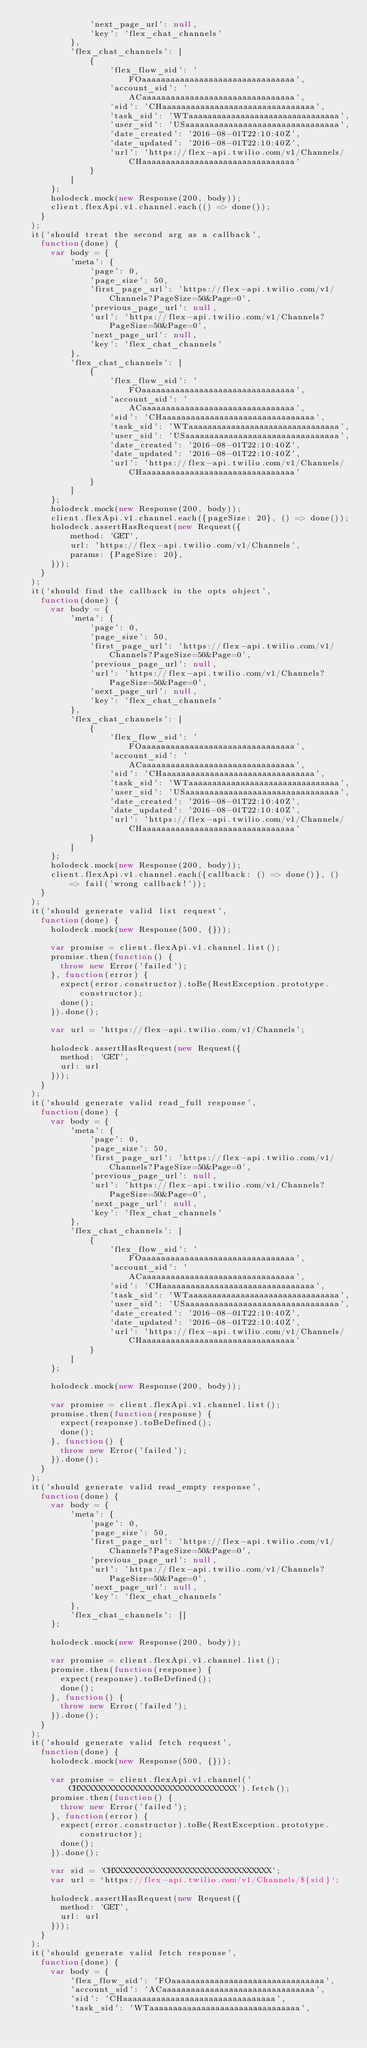Convert code to text. <code><loc_0><loc_0><loc_500><loc_500><_JavaScript_>              'next_page_url': null,
              'key': 'flex_chat_channels'
          },
          'flex_chat_channels': [
              {
                  'flex_flow_sid': 'FOaaaaaaaaaaaaaaaaaaaaaaaaaaaaaaaa',
                  'account_sid': 'ACaaaaaaaaaaaaaaaaaaaaaaaaaaaaaaaa',
                  'sid': 'CHaaaaaaaaaaaaaaaaaaaaaaaaaaaaaaaa',
                  'task_sid': 'WTaaaaaaaaaaaaaaaaaaaaaaaaaaaaaaaa',
                  'user_sid': 'USaaaaaaaaaaaaaaaaaaaaaaaaaaaaaaaa',
                  'date_created': '2016-08-01T22:10:40Z',
                  'date_updated': '2016-08-01T22:10:40Z',
                  'url': 'https://flex-api.twilio.com/v1/Channels/CHaaaaaaaaaaaaaaaaaaaaaaaaaaaaaaaa'
              }
          ]
      };
      holodeck.mock(new Response(200, body));
      client.flexApi.v1.channel.each(() => done());
    }
  );
  it('should treat the second arg as a callback',
    function(done) {
      var body = {
          'meta': {
              'page': 0,
              'page_size': 50,
              'first_page_url': 'https://flex-api.twilio.com/v1/Channels?PageSize=50&Page=0',
              'previous_page_url': null,
              'url': 'https://flex-api.twilio.com/v1/Channels?PageSize=50&Page=0',
              'next_page_url': null,
              'key': 'flex_chat_channels'
          },
          'flex_chat_channels': [
              {
                  'flex_flow_sid': 'FOaaaaaaaaaaaaaaaaaaaaaaaaaaaaaaaa',
                  'account_sid': 'ACaaaaaaaaaaaaaaaaaaaaaaaaaaaaaaaa',
                  'sid': 'CHaaaaaaaaaaaaaaaaaaaaaaaaaaaaaaaa',
                  'task_sid': 'WTaaaaaaaaaaaaaaaaaaaaaaaaaaaaaaaa',
                  'user_sid': 'USaaaaaaaaaaaaaaaaaaaaaaaaaaaaaaaa',
                  'date_created': '2016-08-01T22:10:40Z',
                  'date_updated': '2016-08-01T22:10:40Z',
                  'url': 'https://flex-api.twilio.com/v1/Channels/CHaaaaaaaaaaaaaaaaaaaaaaaaaaaaaaaa'
              }
          ]
      };
      holodeck.mock(new Response(200, body));
      client.flexApi.v1.channel.each({pageSize: 20}, () => done());
      holodeck.assertHasRequest(new Request({
          method: 'GET',
          url: 'https://flex-api.twilio.com/v1/Channels',
          params: {PageSize: 20},
      }));
    }
  );
  it('should find the callback in the opts object',
    function(done) {
      var body = {
          'meta': {
              'page': 0,
              'page_size': 50,
              'first_page_url': 'https://flex-api.twilio.com/v1/Channels?PageSize=50&Page=0',
              'previous_page_url': null,
              'url': 'https://flex-api.twilio.com/v1/Channels?PageSize=50&Page=0',
              'next_page_url': null,
              'key': 'flex_chat_channels'
          },
          'flex_chat_channels': [
              {
                  'flex_flow_sid': 'FOaaaaaaaaaaaaaaaaaaaaaaaaaaaaaaaa',
                  'account_sid': 'ACaaaaaaaaaaaaaaaaaaaaaaaaaaaaaaaa',
                  'sid': 'CHaaaaaaaaaaaaaaaaaaaaaaaaaaaaaaaa',
                  'task_sid': 'WTaaaaaaaaaaaaaaaaaaaaaaaaaaaaaaaa',
                  'user_sid': 'USaaaaaaaaaaaaaaaaaaaaaaaaaaaaaaaa',
                  'date_created': '2016-08-01T22:10:40Z',
                  'date_updated': '2016-08-01T22:10:40Z',
                  'url': 'https://flex-api.twilio.com/v1/Channels/CHaaaaaaaaaaaaaaaaaaaaaaaaaaaaaaaa'
              }
          ]
      };
      holodeck.mock(new Response(200, body));
      client.flexApi.v1.channel.each({callback: () => done()}, () => fail('wrong callback!'));
    }
  );
  it('should generate valid list request',
    function(done) {
      holodeck.mock(new Response(500, {}));

      var promise = client.flexApi.v1.channel.list();
      promise.then(function() {
        throw new Error('failed');
      }, function(error) {
        expect(error.constructor).toBe(RestException.prototype.constructor);
        done();
      }).done();

      var url = 'https://flex-api.twilio.com/v1/Channels';

      holodeck.assertHasRequest(new Request({
        method: 'GET',
        url: url
      }));
    }
  );
  it('should generate valid read_full response',
    function(done) {
      var body = {
          'meta': {
              'page': 0,
              'page_size': 50,
              'first_page_url': 'https://flex-api.twilio.com/v1/Channels?PageSize=50&Page=0',
              'previous_page_url': null,
              'url': 'https://flex-api.twilio.com/v1/Channels?PageSize=50&Page=0',
              'next_page_url': null,
              'key': 'flex_chat_channels'
          },
          'flex_chat_channels': [
              {
                  'flex_flow_sid': 'FOaaaaaaaaaaaaaaaaaaaaaaaaaaaaaaaa',
                  'account_sid': 'ACaaaaaaaaaaaaaaaaaaaaaaaaaaaaaaaa',
                  'sid': 'CHaaaaaaaaaaaaaaaaaaaaaaaaaaaaaaaa',
                  'task_sid': 'WTaaaaaaaaaaaaaaaaaaaaaaaaaaaaaaaa',
                  'user_sid': 'USaaaaaaaaaaaaaaaaaaaaaaaaaaaaaaaa',
                  'date_created': '2016-08-01T22:10:40Z',
                  'date_updated': '2016-08-01T22:10:40Z',
                  'url': 'https://flex-api.twilio.com/v1/Channels/CHaaaaaaaaaaaaaaaaaaaaaaaaaaaaaaaa'
              }
          ]
      };

      holodeck.mock(new Response(200, body));

      var promise = client.flexApi.v1.channel.list();
      promise.then(function(response) {
        expect(response).toBeDefined();
        done();
      }, function() {
        throw new Error('failed');
      }).done();
    }
  );
  it('should generate valid read_empty response',
    function(done) {
      var body = {
          'meta': {
              'page': 0,
              'page_size': 50,
              'first_page_url': 'https://flex-api.twilio.com/v1/Channels?PageSize=50&Page=0',
              'previous_page_url': null,
              'url': 'https://flex-api.twilio.com/v1/Channels?PageSize=50&Page=0',
              'next_page_url': null,
              'key': 'flex_chat_channels'
          },
          'flex_chat_channels': []
      };

      holodeck.mock(new Response(200, body));

      var promise = client.flexApi.v1.channel.list();
      promise.then(function(response) {
        expect(response).toBeDefined();
        done();
      }, function() {
        throw new Error('failed');
      }).done();
    }
  );
  it('should generate valid fetch request',
    function(done) {
      holodeck.mock(new Response(500, {}));

      var promise = client.flexApi.v1.channel('CHXXXXXXXXXXXXXXXXXXXXXXXXXXXXXXXX').fetch();
      promise.then(function() {
        throw new Error('failed');
      }, function(error) {
        expect(error.constructor).toBe(RestException.prototype.constructor);
        done();
      }).done();

      var sid = 'CHXXXXXXXXXXXXXXXXXXXXXXXXXXXXXXXX';
      var url = `https://flex-api.twilio.com/v1/Channels/${sid}`;

      holodeck.assertHasRequest(new Request({
        method: 'GET',
        url: url
      }));
    }
  );
  it('should generate valid fetch response',
    function(done) {
      var body = {
          'flex_flow_sid': 'FOaaaaaaaaaaaaaaaaaaaaaaaaaaaaaaaa',
          'account_sid': 'ACaaaaaaaaaaaaaaaaaaaaaaaaaaaaaaaa',
          'sid': 'CHaaaaaaaaaaaaaaaaaaaaaaaaaaaaaaaa',
          'task_sid': 'WTaaaaaaaaaaaaaaaaaaaaaaaaaaaaaaaa',</code> 